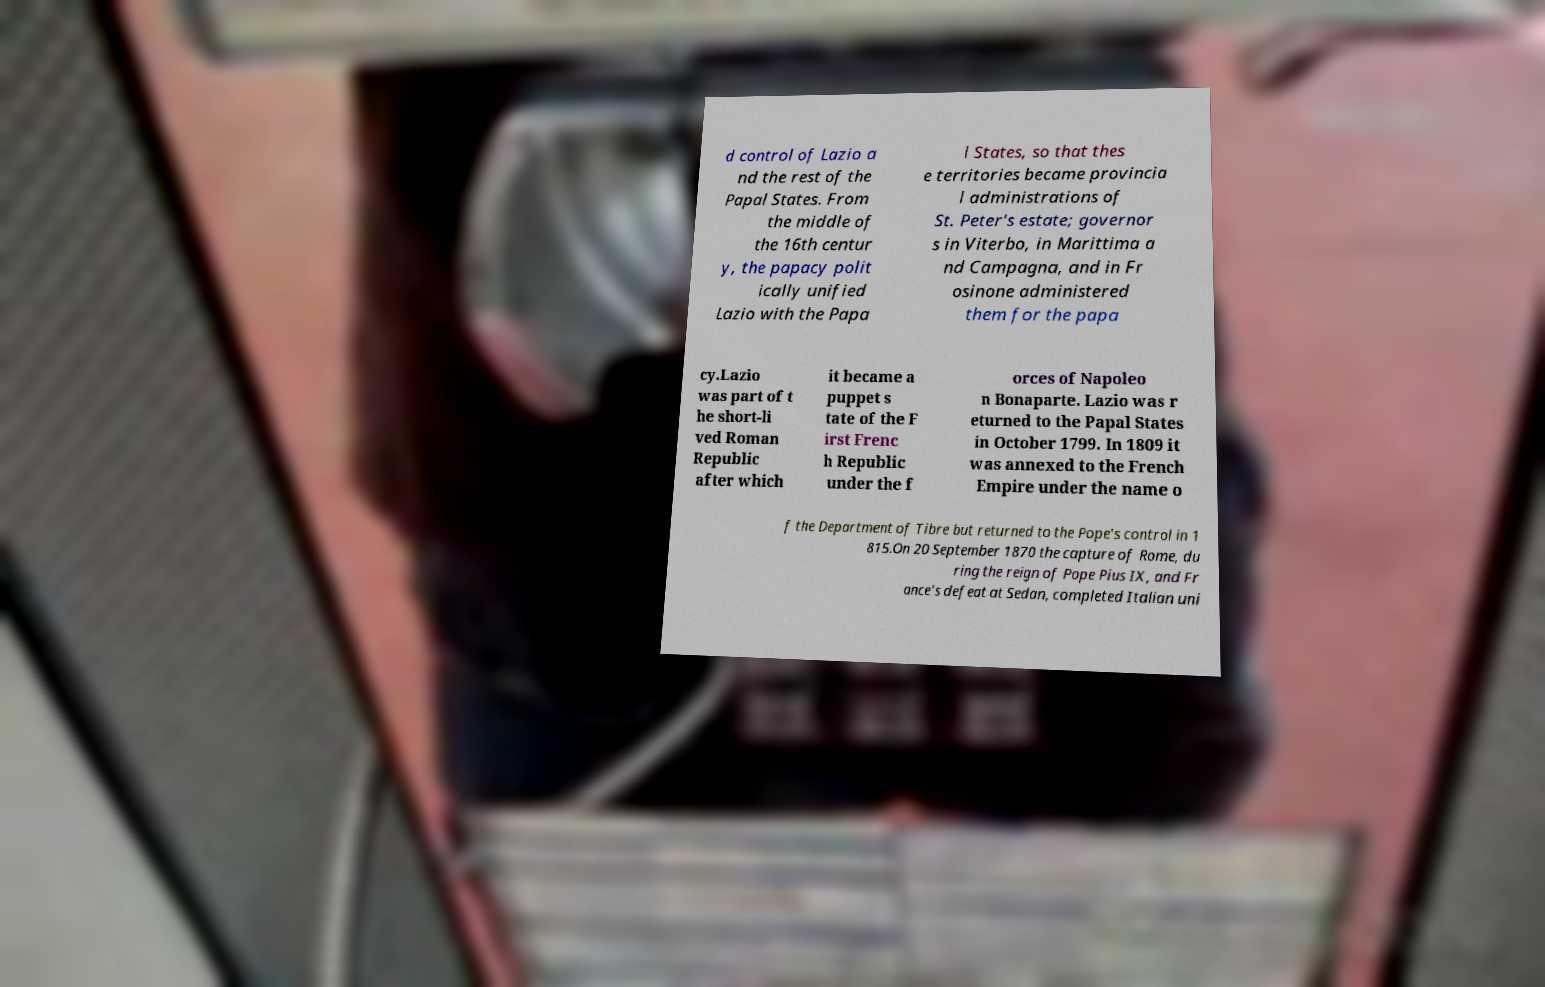I need the written content from this picture converted into text. Can you do that? d control of Lazio a nd the rest of the Papal States. From the middle of the 16th centur y, the papacy polit ically unified Lazio with the Papa l States, so that thes e territories became provincia l administrations of St. Peter's estate; governor s in Viterbo, in Marittima a nd Campagna, and in Fr osinone administered them for the papa cy.Lazio was part of t he short-li ved Roman Republic after which it became a puppet s tate of the F irst Frenc h Republic under the f orces of Napoleo n Bonaparte. Lazio was r eturned to the Papal States in October 1799. In 1809 it was annexed to the French Empire under the name o f the Department of Tibre but returned to the Pope's control in 1 815.On 20 September 1870 the capture of Rome, du ring the reign of Pope Pius IX, and Fr ance's defeat at Sedan, completed Italian uni 